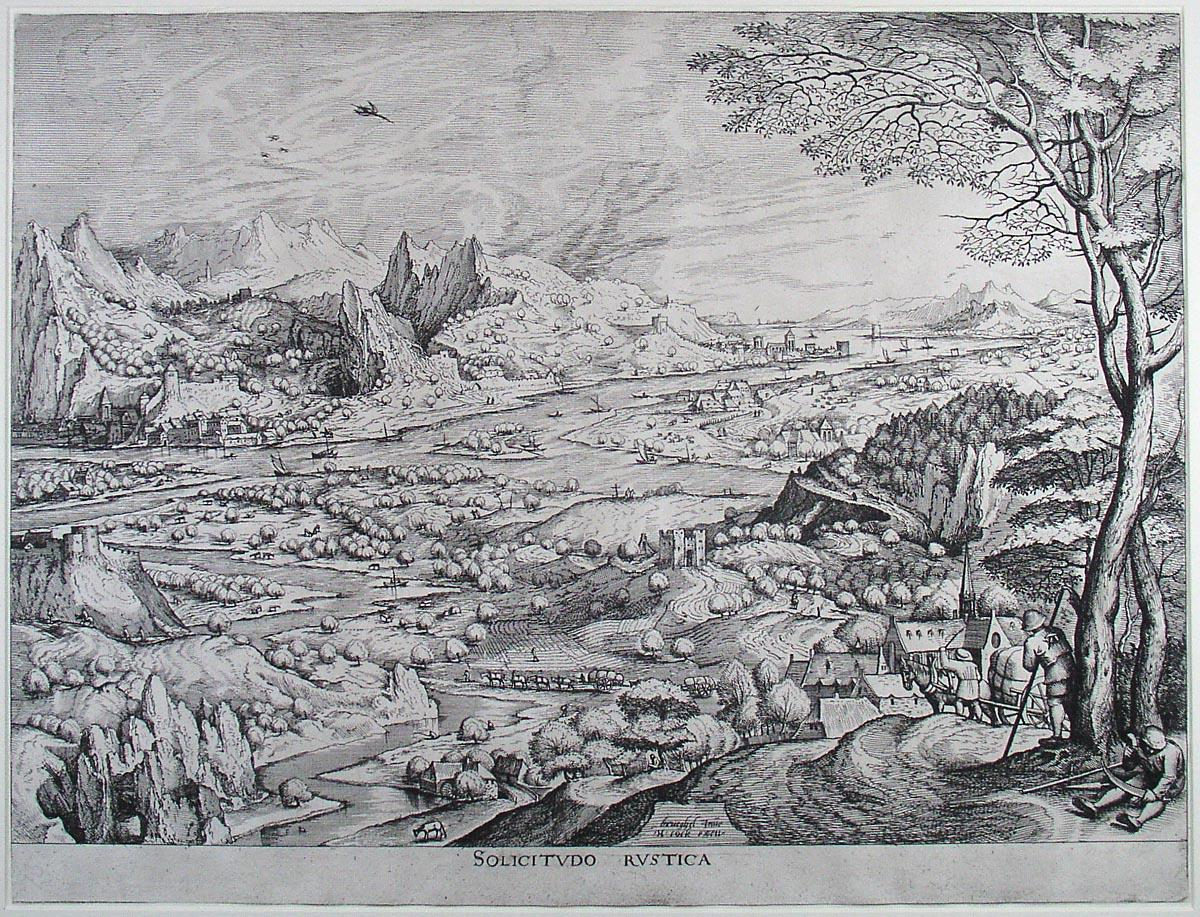Describe the mood conveyed by this etching. The mood of the etching is one of serene tranquility and pastoral peace. The careful rendering of the landscape, with its gently flowing river, verdant fields, and distant mountains, evokes a sense of calm and timelessness. The farmers tending to their land and the quaint villages exude a sense of harmony and connection to nature. The overall atmosphere is peaceful, yet full of life and detailed observation, characteristic of an idealized rural world. What might be the symbolic significance of the mountains in the background? The mountains in the background could symbolize stability and permanence, standing as timeless sentinels over the ever-changing rural landscape. They may represent the constant and enduring presence of nature amidst the activities and lives of the people depicted in the scene. Additionally, mountains often symbolize aspiration and the pursuit of higher ideals or spiritual enlightenment, adding a layer of depth to the bucolic setting. 